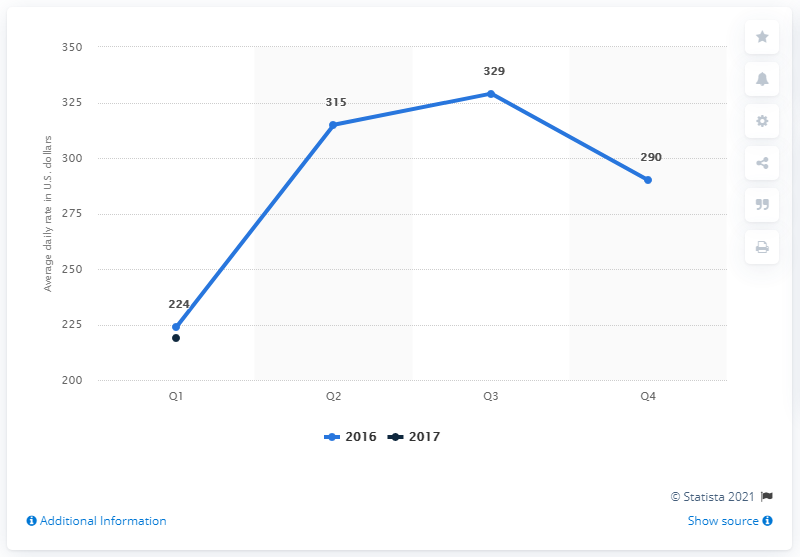Mention a couple of crucial points in this snapshot. The average cost for Q3 and Q4 in 2016 was 309.5. According to data from the first quarter of 2017, the average daily rate of hotels in Boston was approximately $219. In 2016, the rate of hotels in the fourth quarter was 290. 